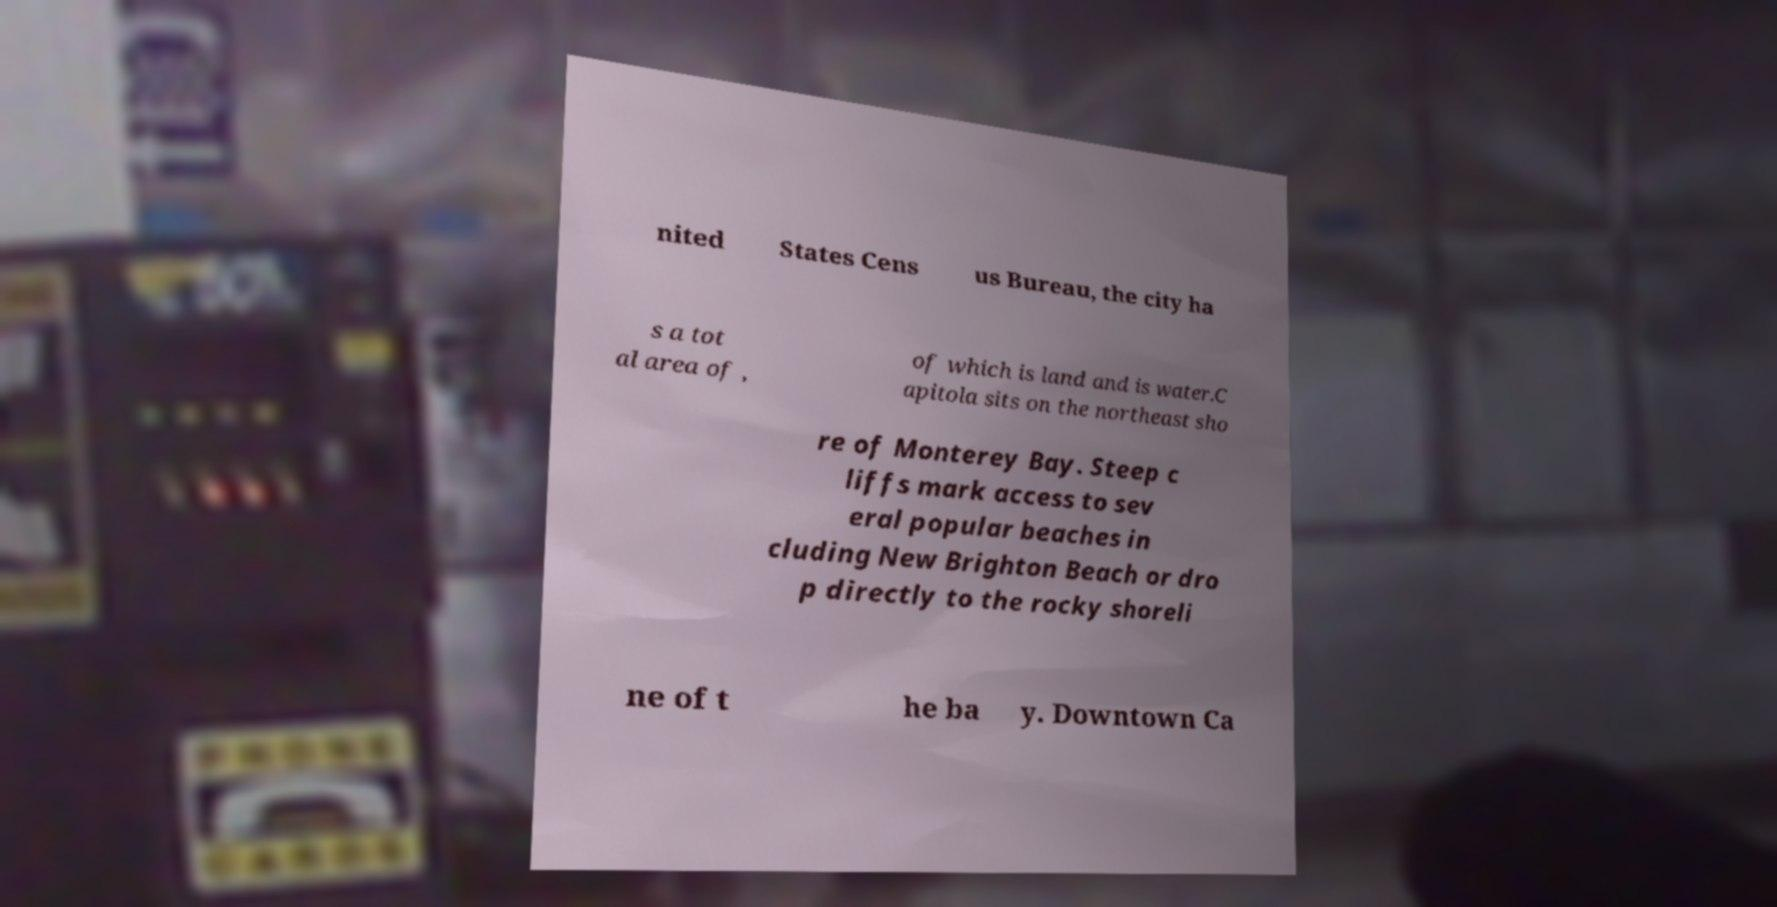There's text embedded in this image that I need extracted. Can you transcribe it verbatim? nited States Cens us Bureau, the city ha s a tot al area of , of which is land and is water.C apitola sits on the northeast sho re of Monterey Bay. Steep c liffs mark access to sev eral popular beaches in cluding New Brighton Beach or dro p directly to the rocky shoreli ne of t he ba y. Downtown Ca 